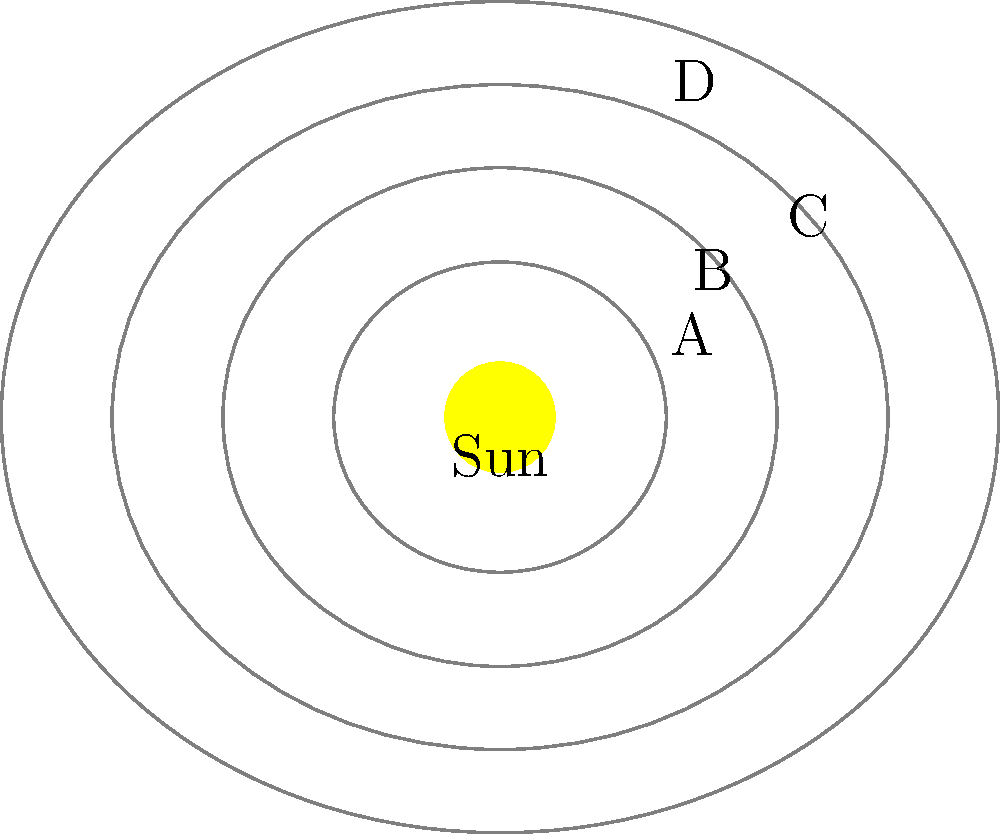In the diagram above, which planet's orbit most closely resembles that of Mars in our solar system, and how does this relate to Johannes Kepler's laws of planetary motion? To answer this question, we need to consider the following steps:

1. Recall that Mars is the fourth planet from the Sun in our solar system.

2. Observe the diagram, which shows four planets (A, B, C, and D) orbiting the Sun in elliptical orbits.

3. Notice that planet D has the fourth orbit from the Sun, corresponding to Mars' position in our solar system.

4. Recognize that the elliptical shape of planet D's orbit is more pronounced than the others, which is consistent with Mars' actual orbit.

5. Recall Kepler's First Law of Planetary Motion: The orbit of each planet is an ellipse with the Sun at one of the two foci.

6. Observe that all orbits in the diagram are elliptical, following Kepler's First Law.

7. Consider Kepler's Second Law: A line segment joining a planet and the Sun sweeps out equal areas during equal intervals of time. This is not directly visible in the static image but is implied by the elliptical orbits.

8. Remember Kepler's Third Law: The square of the orbital period of a planet is directly proportional to the cube of the semi-major axis of its orbit. This relationship is suggested by the increasing sizes of the orbits in the diagram.

9. Conclude that planet D's orbit most closely resembles Mars' orbit in our solar system, demonstrating a more pronounced elliptical shape while adhering to Kepler's laws of planetary motion.
Answer: Planet D; it demonstrates a pronounced elliptical orbit consistent with Kepler's laws. 